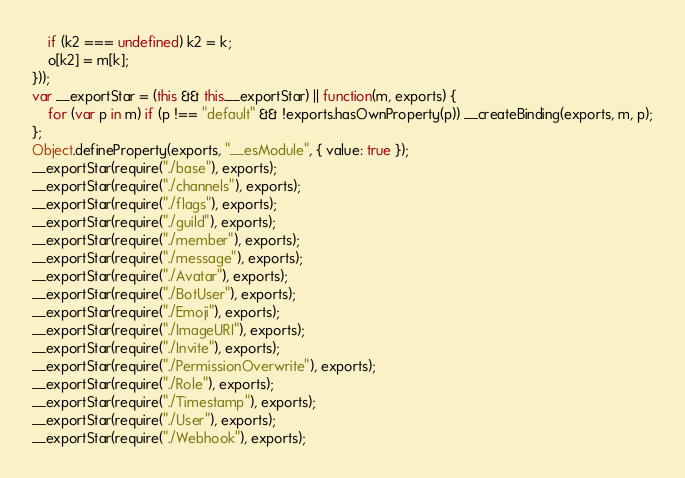Convert code to text. <code><loc_0><loc_0><loc_500><loc_500><_JavaScript_>    if (k2 === undefined) k2 = k;
    o[k2] = m[k];
}));
var __exportStar = (this && this.__exportStar) || function(m, exports) {
    for (var p in m) if (p !== "default" && !exports.hasOwnProperty(p)) __createBinding(exports, m, p);
};
Object.defineProperty(exports, "__esModule", { value: true });
__exportStar(require("./base"), exports);
__exportStar(require("./channels"), exports);
__exportStar(require("./flags"), exports);
__exportStar(require("./guild"), exports);
__exportStar(require("./member"), exports);
__exportStar(require("./message"), exports);
__exportStar(require("./Avatar"), exports);
__exportStar(require("./BotUser"), exports);
__exportStar(require("./Emoji"), exports);
__exportStar(require("./ImageURI"), exports);
__exportStar(require("./Invite"), exports);
__exportStar(require("./PermissionOverwrite"), exports);
__exportStar(require("./Role"), exports);
__exportStar(require("./Timestamp"), exports);
__exportStar(require("./User"), exports);
__exportStar(require("./Webhook"), exports);
</code> 